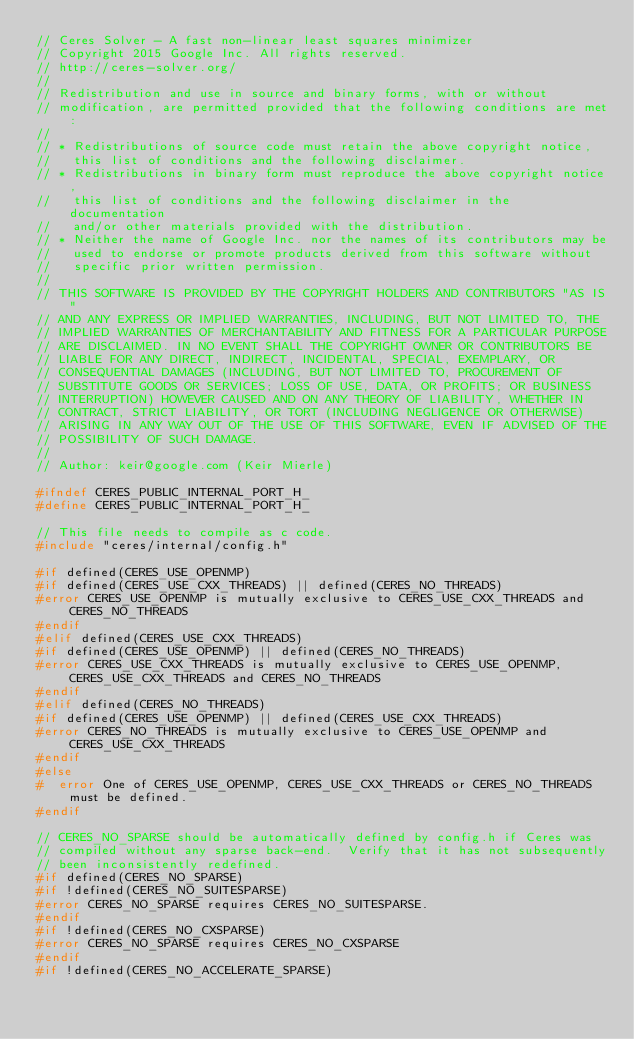<code> <loc_0><loc_0><loc_500><loc_500><_C_>// Ceres Solver - A fast non-linear least squares minimizer
// Copyright 2015 Google Inc. All rights reserved.
// http://ceres-solver.org/
//
// Redistribution and use in source and binary forms, with or without
// modification, are permitted provided that the following conditions are met:
//
// * Redistributions of source code must retain the above copyright notice,
//   this list of conditions and the following disclaimer.
// * Redistributions in binary form must reproduce the above copyright notice,
//   this list of conditions and the following disclaimer in the documentation
//   and/or other materials provided with the distribution.
// * Neither the name of Google Inc. nor the names of its contributors may be
//   used to endorse or promote products derived from this software without
//   specific prior written permission.
//
// THIS SOFTWARE IS PROVIDED BY THE COPYRIGHT HOLDERS AND CONTRIBUTORS "AS IS"
// AND ANY EXPRESS OR IMPLIED WARRANTIES, INCLUDING, BUT NOT LIMITED TO, THE
// IMPLIED WARRANTIES OF MERCHANTABILITY AND FITNESS FOR A PARTICULAR PURPOSE
// ARE DISCLAIMED. IN NO EVENT SHALL THE COPYRIGHT OWNER OR CONTRIBUTORS BE
// LIABLE FOR ANY DIRECT, INDIRECT, INCIDENTAL, SPECIAL, EXEMPLARY, OR
// CONSEQUENTIAL DAMAGES (INCLUDING, BUT NOT LIMITED TO, PROCUREMENT OF
// SUBSTITUTE GOODS OR SERVICES; LOSS OF USE, DATA, OR PROFITS; OR BUSINESS
// INTERRUPTION) HOWEVER CAUSED AND ON ANY THEORY OF LIABILITY, WHETHER IN
// CONTRACT, STRICT LIABILITY, OR TORT (INCLUDING NEGLIGENCE OR OTHERWISE)
// ARISING IN ANY WAY OUT OF THE USE OF THIS SOFTWARE, EVEN IF ADVISED OF THE
// POSSIBILITY OF SUCH DAMAGE.
//
// Author: keir@google.com (Keir Mierle)

#ifndef CERES_PUBLIC_INTERNAL_PORT_H_
#define CERES_PUBLIC_INTERNAL_PORT_H_

// This file needs to compile as c code.
#include "ceres/internal/config.h"

#if defined(CERES_USE_OPENMP)
#if defined(CERES_USE_CXX_THREADS) || defined(CERES_NO_THREADS)
#error CERES_USE_OPENMP is mutually exclusive to CERES_USE_CXX_THREADS and CERES_NO_THREADS
#endif
#elif defined(CERES_USE_CXX_THREADS)
#if defined(CERES_USE_OPENMP) || defined(CERES_NO_THREADS)
#error CERES_USE_CXX_THREADS is mutually exclusive to CERES_USE_OPENMP, CERES_USE_CXX_THREADS and CERES_NO_THREADS
#endif
#elif defined(CERES_NO_THREADS)
#if defined(CERES_USE_OPENMP) || defined(CERES_USE_CXX_THREADS)
#error CERES_NO_THREADS is mutually exclusive to CERES_USE_OPENMP and CERES_USE_CXX_THREADS
#endif
#else
#  error One of CERES_USE_OPENMP, CERES_USE_CXX_THREADS or CERES_NO_THREADS must be defined.
#endif

// CERES_NO_SPARSE should be automatically defined by config.h if Ceres was
// compiled without any sparse back-end.  Verify that it has not subsequently
// been inconsistently redefined.
#if defined(CERES_NO_SPARSE)
#if !defined(CERES_NO_SUITESPARSE)
#error CERES_NO_SPARSE requires CERES_NO_SUITESPARSE.
#endif
#if !defined(CERES_NO_CXSPARSE)
#error CERES_NO_SPARSE requires CERES_NO_CXSPARSE
#endif
#if !defined(CERES_NO_ACCELERATE_SPARSE)</code> 